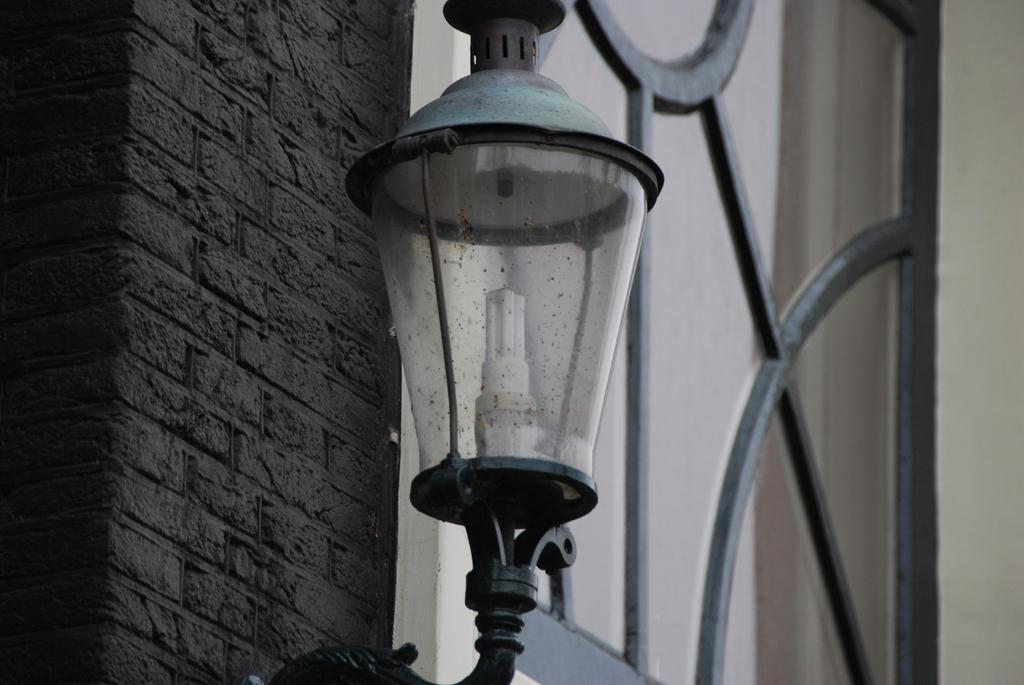What is the main object in the center of the image? There is a light in the center of the image. What can be seen in the background of the image? There is a window and a wall in the background of the image. What type of lunch is being served in the image? There is no lunch present in the image; it only features a light and a background with a window and a wall. 